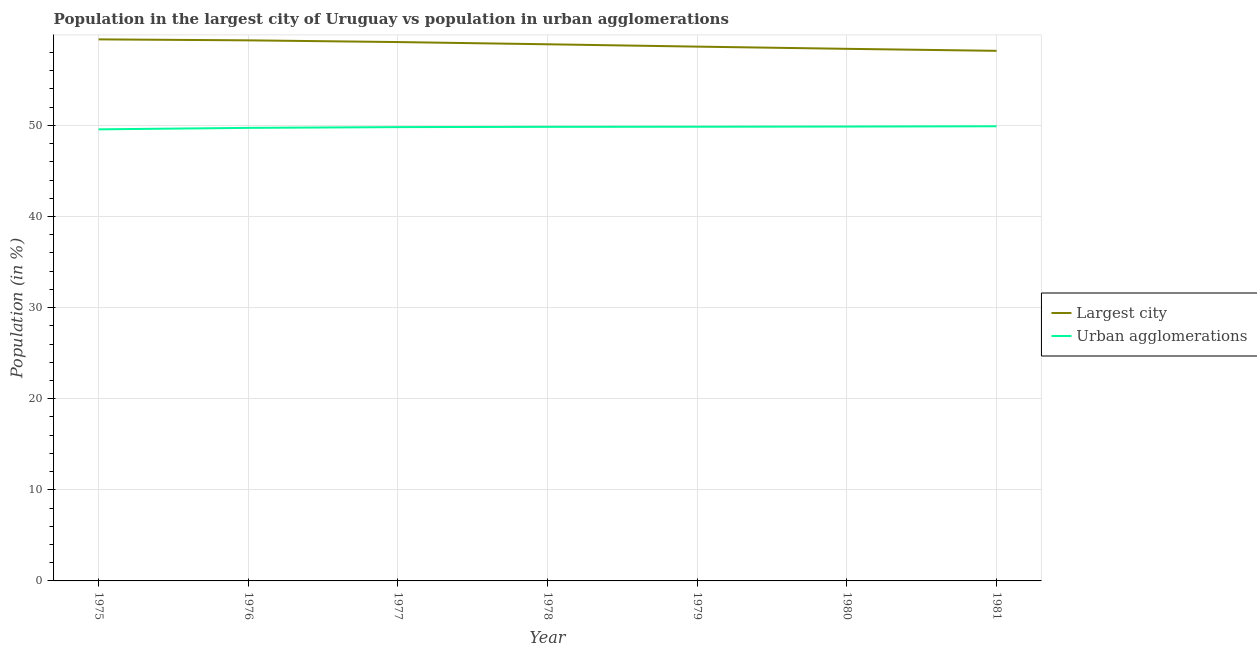How many different coloured lines are there?
Ensure brevity in your answer.  2. Does the line corresponding to population in the largest city intersect with the line corresponding to population in urban agglomerations?
Offer a very short reply. No. Is the number of lines equal to the number of legend labels?
Offer a terse response. Yes. What is the population in the largest city in 1979?
Ensure brevity in your answer.  58.65. Across all years, what is the maximum population in the largest city?
Offer a terse response. 59.45. Across all years, what is the minimum population in urban agglomerations?
Provide a short and direct response. 49.57. In which year was the population in the largest city maximum?
Make the answer very short. 1975. In which year was the population in urban agglomerations minimum?
Your answer should be compact. 1975. What is the total population in urban agglomerations in the graph?
Make the answer very short. 348.6. What is the difference between the population in the largest city in 1976 and that in 1979?
Make the answer very short. 0.69. What is the difference between the population in the largest city in 1976 and the population in urban agglomerations in 1978?
Offer a terse response. 9.5. What is the average population in the largest city per year?
Your response must be concise. 58.87. In the year 1976, what is the difference between the population in the largest city and population in urban agglomerations?
Ensure brevity in your answer.  9.61. What is the ratio of the population in the largest city in 1976 to that in 1979?
Your answer should be compact. 1.01. Is the population in urban agglomerations in 1975 less than that in 1976?
Make the answer very short. Yes. What is the difference between the highest and the second highest population in the largest city?
Offer a very short reply. 0.11. What is the difference between the highest and the lowest population in the largest city?
Your answer should be very brief. 1.26. Does the population in the largest city monotonically increase over the years?
Your answer should be very brief. No. How many lines are there?
Give a very brief answer. 2. What is the difference between two consecutive major ticks on the Y-axis?
Provide a succinct answer. 10. Does the graph contain any zero values?
Provide a short and direct response. No. Where does the legend appear in the graph?
Make the answer very short. Center right. How many legend labels are there?
Your answer should be compact. 2. What is the title of the graph?
Give a very brief answer. Population in the largest city of Uruguay vs population in urban agglomerations. What is the label or title of the X-axis?
Provide a succinct answer. Year. What is the label or title of the Y-axis?
Provide a short and direct response. Population (in %). What is the Population (in %) of Largest city in 1975?
Make the answer very short. 59.45. What is the Population (in %) in Urban agglomerations in 1975?
Provide a short and direct response. 49.57. What is the Population (in %) of Largest city in 1976?
Ensure brevity in your answer.  59.34. What is the Population (in %) of Urban agglomerations in 1976?
Provide a succinct answer. 49.73. What is the Population (in %) in Largest city in 1977?
Provide a succinct answer. 59.15. What is the Population (in %) in Urban agglomerations in 1977?
Your response must be concise. 49.81. What is the Population (in %) of Largest city in 1978?
Give a very brief answer. 58.91. What is the Population (in %) in Urban agglomerations in 1978?
Give a very brief answer. 49.84. What is the Population (in %) of Largest city in 1979?
Give a very brief answer. 58.65. What is the Population (in %) of Urban agglomerations in 1979?
Give a very brief answer. 49.86. What is the Population (in %) in Largest city in 1980?
Offer a terse response. 58.41. What is the Population (in %) in Urban agglomerations in 1980?
Provide a succinct answer. 49.88. What is the Population (in %) in Largest city in 1981?
Keep it short and to the point. 58.19. What is the Population (in %) in Urban agglomerations in 1981?
Offer a terse response. 49.91. Across all years, what is the maximum Population (in %) of Largest city?
Your answer should be very brief. 59.45. Across all years, what is the maximum Population (in %) of Urban agglomerations?
Your response must be concise. 49.91. Across all years, what is the minimum Population (in %) in Largest city?
Give a very brief answer. 58.19. Across all years, what is the minimum Population (in %) of Urban agglomerations?
Ensure brevity in your answer.  49.57. What is the total Population (in %) of Largest city in the graph?
Your response must be concise. 412.09. What is the total Population (in %) of Urban agglomerations in the graph?
Provide a succinct answer. 348.6. What is the difference between the Population (in %) in Largest city in 1975 and that in 1976?
Provide a succinct answer. 0.11. What is the difference between the Population (in %) in Urban agglomerations in 1975 and that in 1976?
Your answer should be very brief. -0.16. What is the difference between the Population (in %) of Largest city in 1975 and that in 1977?
Your response must be concise. 0.29. What is the difference between the Population (in %) in Urban agglomerations in 1975 and that in 1977?
Keep it short and to the point. -0.24. What is the difference between the Population (in %) in Largest city in 1975 and that in 1978?
Your answer should be compact. 0.54. What is the difference between the Population (in %) in Urban agglomerations in 1975 and that in 1978?
Your response must be concise. -0.27. What is the difference between the Population (in %) in Largest city in 1975 and that in 1979?
Your answer should be very brief. 0.8. What is the difference between the Population (in %) in Urban agglomerations in 1975 and that in 1979?
Provide a succinct answer. -0.29. What is the difference between the Population (in %) of Largest city in 1975 and that in 1980?
Your answer should be very brief. 1.04. What is the difference between the Population (in %) of Urban agglomerations in 1975 and that in 1980?
Provide a succinct answer. -0.31. What is the difference between the Population (in %) of Largest city in 1975 and that in 1981?
Provide a short and direct response. 1.26. What is the difference between the Population (in %) of Urban agglomerations in 1975 and that in 1981?
Your answer should be compact. -0.34. What is the difference between the Population (in %) of Largest city in 1976 and that in 1977?
Keep it short and to the point. 0.19. What is the difference between the Population (in %) in Urban agglomerations in 1976 and that in 1977?
Provide a succinct answer. -0.08. What is the difference between the Population (in %) in Largest city in 1976 and that in 1978?
Your answer should be compact. 0.43. What is the difference between the Population (in %) of Urban agglomerations in 1976 and that in 1978?
Make the answer very short. -0.11. What is the difference between the Population (in %) of Largest city in 1976 and that in 1979?
Your response must be concise. 0.69. What is the difference between the Population (in %) of Urban agglomerations in 1976 and that in 1979?
Give a very brief answer. -0.13. What is the difference between the Population (in %) of Largest city in 1976 and that in 1980?
Your answer should be very brief. 0.93. What is the difference between the Population (in %) in Urban agglomerations in 1976 and that in 1980?
Offer a very short reply. -0.15. What is the difference between the Population (in %) of Largest city in 1976 and that in 1981?
Your answer should be very brief. 1.15. What is the difference between the Population (in %) of Urban agglomerations in 1976 and that in 1981?
Provide a succinct answer. -0.18. What is the difference between the Population (in %) of Largest city in 1977 and that in 1978?
Provide a succinct answer. 0.24. What is the difference between the Population (in %) of Urban agglomerations in 1977 and that in 1978?
Offer a very short reply. -0.03. What is the difference between the Population (in %) in Largest city in 1977 and that in 1979?
Provide a short and direct response. 0.5. What is the difference between the Population (in %) of Urban agglomerations in 1977 and that in 1979?
Provide a succinct answer. -0.04. What is the difference between the Population (in %) in Largest city in 1977 and that in 1980?
Make the answer very short. 0.74. What is the difference between the Population (in %) of Urban agglomerations in 1977 and that in 1980?
Make the answer very short. -0.06. What is the difference between the Population (in %) in Largest city in 1977 and that in 1981?
Offer a very short reply. 0.96. What is the difference between the Population (in %) of Urban agglomerations in 1977 and that in 1981?
Offer a terse response. -0.09. What is the difference between the Population (in %) in Largest city in 1978 and that in 1979?
Keep it short and to the point. 0.26. What is the difference between the Population (in %) of Urban agglomerations in 1978 and that in 1979?
Ensure brevity in your answer.  -0.01. What is the difference between the Population (in %) of Largest city in 1978 and that in 1980?
Offer a terse response. 0.5. What is the difference between the Population (in %) in Urban agglomerations in 1978 and that in 1980?
Give a very brief answer. -0.03. What is the difference between the Population (in %) in Largest city in 1978 and that in 1981?
Offer a very short reply. 0.72. What is the difference between the Population (in %) in Urban agglomerations in 1978 and that in 1981?
Provide a succinct answer. -0.06. What is the difference between the Population (in %) of Largest city in 1979 and that in 1980?
Make the answer very short. 0.24. What is the difference between the Population (in %) in Urban agglomerations in 1979 and that in 1980?
Offer a very short reply. -0.02. What is the difference between the Population (in %) in Largest city in 1979 and that in 1981?
Ensure brevity in your answer.  0.46. What is the difference between the Population (in %) of Largest city in 1980 and that in 1981?
Offer a very short reply. 0.22. What is the difference between the Population (in %) of Urban agglomerations in 1980 and that in 1981?
Give a very brief answer. -0.03. What is the difference between the Population (in %) in Largest city in 1975 and the Population (in %) in Urban agglomerations in 1976?
Your answer should be very brief. 9.72. What is the difference between the Population (in %) in Largest city in 1975 and the Population (in %) in Urban agglomerations in 1977?
Offer a terse response. 9.63. What is the difference between the Population (in %) in Largest city in 1975 and the Population (in %) in Urban agglomerations in 1978?
Offer a very short reply. 9.6. What is the difference between the Population (in %) in Largest city in 1975 and the Population (in %) in Urban agglomerations in 1979?
Your answer should be compact. 9.59. What is the difference between the Population (in %) of Largest city in 1975 and the Population (in %) of Urban agglomerations in 1980?
Keep it short and to the point. 9.57. What is the difference between the Population (in %) in Largest city in 1975 and the Population (in %) in Urban agglomerations in 1981?
Your response must be concise. 9.54. What is the difference between the Population (in %) of Largest city in 1976 and the Population (in %) of Urban agglomerations in 1977?
Your response must be concise. 9.53. What is the difference between the Population (in %) in Largest city in 1976 and the Population (in %) in Urban agglomerations in 1978?
Offer a terse response. 9.5. What is the difference between the Population (in %) of Largest city in 1976 and the Population (in %) of Urban agglomerations in 1979?
Your response must be concise. 9.48. What is the difference between the Population (in %) of Largest city in 1976 and the Population (in %) of Urban agglomerations in 1980?
Offer a terse response. 9.46. What is the difference between the Population (in %) of Largest city in 1976 and the Population (in %) of Urban agglomerations in 1981?
Keep it short and to the point. 9.43. What is the difference between the Population (in %) of Largest city in 1977 and the Population (in %) of Urban agglomerations in 1978?
Offer a very short reply. 9.31. What is the difference between the Population (in %) of Largest city in 1977 and the Population (in %) of Urban agglomerations in 1979?
Offer a very short reply. 9.29. What is the difference between the Population (in %) in Largest city in 1977 and the Population (in %) in Urban agglomerations in 1980?
Make the answer very short. 9.27. What is the difference between the Population (in %) of Largest city in 1977 and the Population (in %) of Urban agglomerations in 1981?
Ensure brevity in your answer.  9.24. What is the difference between the Population (in %) in Largest city in 1978 and the Population (in %) in Urban agglomerations in 1979?
Provide a short and direct response. 9.05. What is the difference between the Population (in %) of Largest city in 1978 and the Population (in %) of Urban agglomerations in 1980?
Keep it short and to the point. 9.03. What is the difference between the Population (in %) in Largest city in 1978 and the Population (in %) in Urban agglomerations in 1981?
Your response must be concise. 9. What is the difference between the Population (in %) in Largest city in 1979 and the Population (in %) in Urban agglomerations in 1980?
Offer a very short reply. 8.77. What is the difference between the Population (in %) in Largest city in 1979 and the Population (in %) in Urban agglomerations in 1981?
Offer a terse response. 8.74. What is the difference between the Population (in %) of Largest city in 1980 and the Population (in %) of Urban agglomerations in 1981?
Offer a terse response. 8.5. What is the average Population (in %) of Largest city per year?
Keep it short and to the point. 58.87. What is the average Population (in %) of Urban agglomerations per year?
Make the answer very short. 49.8. In the year 1975, what is the difference between the Population (in %) of Largest city and Population (in %) of Urban agglomerations?
Keep it short and to the point. 9.88. In the year 1976, what is the difference between the Population (in %) of Largest city and Population (in %) of Urban agglomerations?
Your answer should be compact. 9.61. In the year 1977, what is the difference between the Population (in %) of Largest city and Population (in %) of Urban agglomerations?
Provide a short and direct response. 9.34. In the year 1978, what is the difference between the Population (in %) of Largest city and Population (in %) of Urban agglomerations?
Your response must be concise. 9.06. In the year 1979, what is the difference between the Population (in %) in Largest city and Population (in %) in Urban agglomerations?
Give a very brief answer. 8.79. In the year 1980, what is the difference between the Population (in %) of Largest city and Population (in %) of Urban agglomerations?
Ensure brevity in your answer.  8.53. In the year 1981, what is the difference between the Population (in %) in Largest city and Population (in %) in Urban agglomerations?
Make the answer very short. 8.28. What is the ratio of the Population (in %) of Largest city in 1975 to that in 1976?
Your answer should be very brief. 1. What is the ratio of the Population (in %) of Urban agglomerations in 1975 to that in 1976?
Provide a short and direct response. 1. What is the ratio of the Population (in %) in Largest city in 1975 to that in 1977?
Provide a succinct answer. 1. What is the ratio of the Population (in %) of Urban agglomerations in 1975 to that in 1977?
Give a very brief answer. 1. What is the ratio of the Population (in %) in Largest city in 1975 to that in 1978?
Your response must be concise. 1.01. What is the ratio of the Population (in %) in Largest city in 1975 to that in 1979?
Your answer should be very brief. 1.01. What is the ratio of the Population (in %) of Largest city in 1975 to that in 1980?
Your answer should be very brief. 1.02. What is the ratio of the Population (in %) of Urban agglomerations in 1975 to that in 1980?
Offer a very short reply. 0.99. What is the ratio of the Population (in %) in Largest city in 1975 to that in 1981?
Your answer should be very brief. 1.02. What is the ratio of the Population (in %) of Largest city in 1976 to that in 1977?
Your answer should be compact. 1. What is the ratio of the Population (in %) of Urban agglomerations in 1976 to that in 1977?
Your answer should be very brief. 1. What is the ratio of the Population (in %) in Largest city in 1976 to that in 1978?
Make the answer very short. 1.01. What is the ratio of the Population (in %) of Largest city in 1976 to that in 1979?
Your response must be concise. 1.01. What is the ratio of the Population (in %) of Urban agglomerations in 1976 to that in 1979?
Your answer should be very brief. 1. What is the ratio of the Population (in %) in Urban agglomerations in 1976 to that in 1980?
Ensure brevity in your answer.  1. What is the ratio of the Population (in %) in Largest city in 1976 to that in 1981?
Make the answer very short. 1.02. What is the ratio of the Population (in %) of Largest city in 1977 to that in 1978?
Make the answer very short. 1. What is the ratio of the Population (in %) in Largest city in 1977 to that in 1979?
Your response must be concise. 1.01. What is the ratio of the Population (in %) of Largest city in 1977 to that in 1980?
Make the answer very short. 1.01. What is the ratio of the Population (in %) in Largest city in 1977 to that in 1981?
Your answer should be very brief. 1.02. What is the ratio of the Population (in %) of Urban agglomerations in 1977 to that in 1981?
Provide a succinct answer. 1. What is the ratio of the Population (in %) in Urban agglomerations in 1978 to that in 1979?
Provide a short and direct response. 1. What is the ratio of the Population (in %) in Largest city in 1978 to that in 1980?
Your answer should be compact. 1.01. What is the ratio of the Population (in %) of Largest city in 1978 to that in 1981?
Your answer should be compact. 1.01. What is the ratio of the Population (in %) in Urban agglomerations in 1978 to that in 1981?
Provide a short and direct response. 1. What is the ratio of the Population (in %) of Largest city in 1979 to that in 1980?
Make the answer very short. 1. What is the ratio of the Population (in %) in Largest city in 1979 to that in 1981?
Keep it short and to the point. 1.01. What is the ratio of the Population (in %) in Largest city in 1980 to that in 1981?
Provide a succinct answer. 1. What is the ratio of the Population (in %) in Urban agglomerations in 1980 to that in 1981?
Offer a very short reply. 1. What is the difference between the highest and the second highest Population (in %) in Largest city?
Provide a short and direct response. 0.11. What is the difference between the highest and the second highest Population (in %) in Urban agglomerations?
Your response must be concise. 0.03. What is the difference between the highest and the lowest Population (in %) of Largest city?
Ensure brevity in your answer.  1.26. What is the difference between the highest and the lowest Population (in %) of Urban agglomerations?
Your answer should be compact. 0.34. 